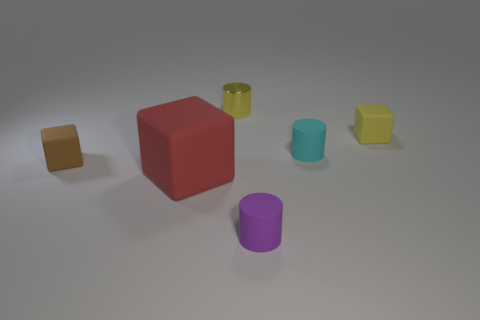Are there any other things that have the same material as the tiny yellow cylinder?
Offer a terse response. No. There is a rubber cube to the right of the purple rubber object; is it the same size as the large matte object?
Your answer should be compact. No. The other tiny rubber thing that is the same shape as the small cyan matte object is what color?
Offer a very short reply. Purple. Is there any other thing that is the same shape as the tiny brown rubber thing?
Your response must be concise. Yes. The small matte thing that is left of the purple rubber object has what shape?
Give a very brief answer. Cube. What number of other rubber things are the same shape as the small brown rubber object?
Your answer should be compact. 2. Is the color of the tiny matte object that is to the left of the big red cube the same as the block in front of the brown cube?
Provide a succinct answer. No. How many objects are either tiny metal cylinders or tiny rubber cubes?
Give a very brief answer. 3. How many tiny blocks have the same material as the brown thing?
Your answer should be compact. 1. Are there fewer tiny purple matte cylinders than brown metal cylinders?
Your answer should be very brief. No. 